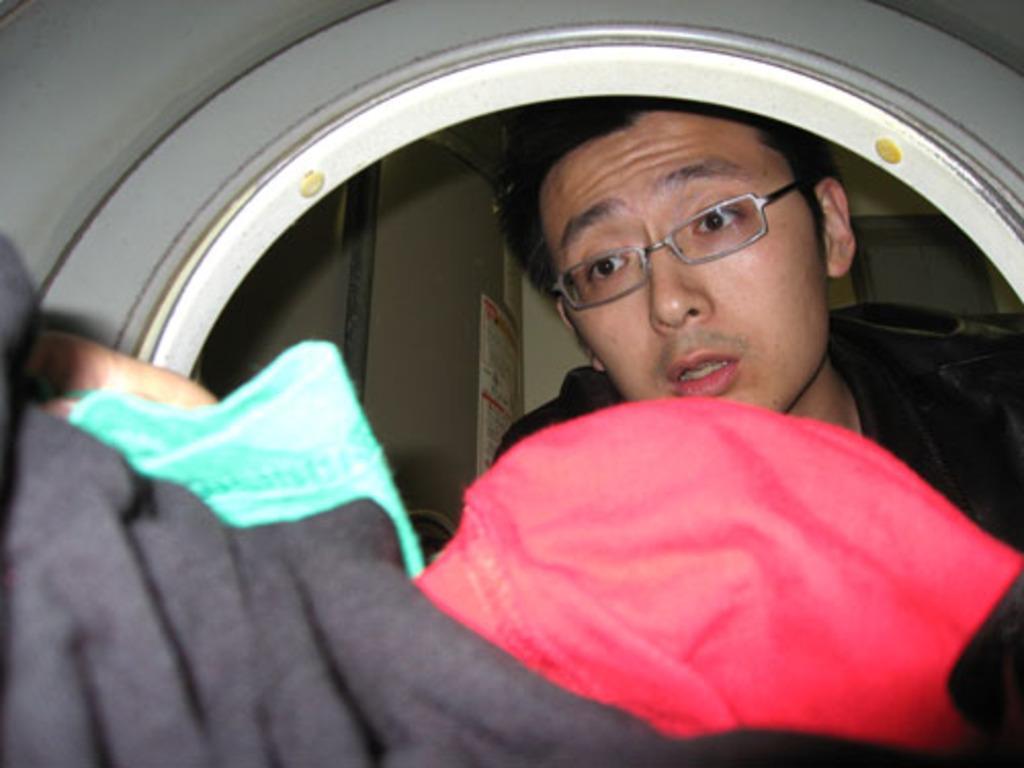In one or two sentences, can you explain what this image depicts? It is looking like, the picture is taken inside a washing machine. In the foreground there are clothes. In the middle of the picture we can see a person. In the background we can see posters sticked to the wall. 